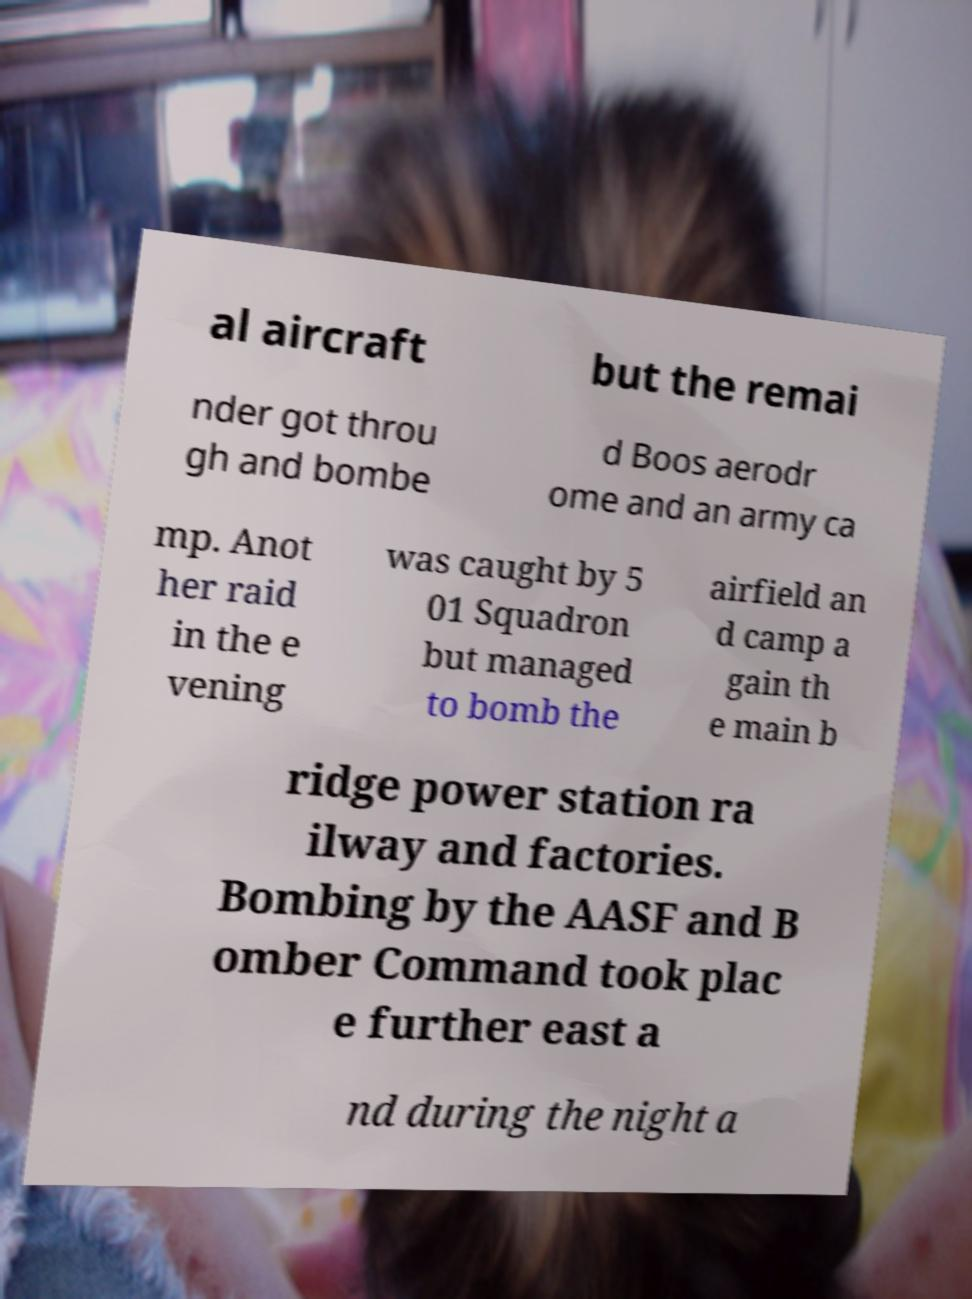Can you read and provide the text displayed in the image?This photo seems to have some interesting text. Can you extract and type it out for me? al aircraft but the remai nder got throu gh and bombe d Boos aerodr ome and an army ca mp. Anot her raid in the e vening was caught by 5 01 Squadron but managed to bomb the airfield an d camp a gain th e main b ridge power station ra ilway and factories. Bombing by the AASF and B omber Command took plac e further east a nd during the night a 